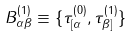Convert formula to latex. <formula><loc_0><loc_0><loc_500><loc_500>B _ { \alpha \beta } ^ { ( 1 ) } \equiv \{ \tau _ { [ \alpha } ^ { ( 0 ) } , \tau _ { \beta ] } ^ { ( 1 ) } \}</formula> 